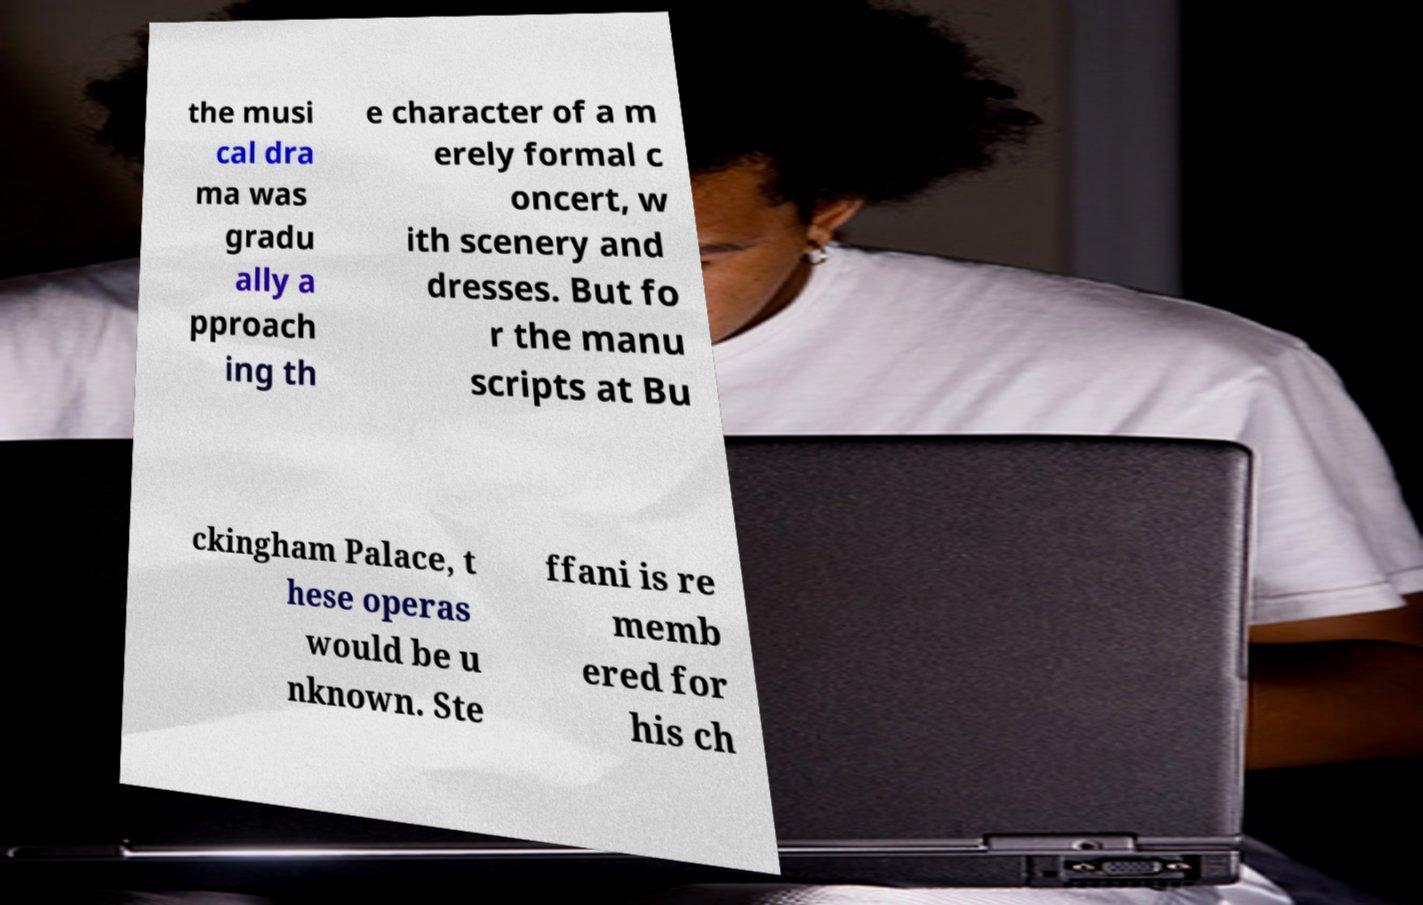For documentation purposes, I need the text within this image transcribed. Could you provide that? the musi cal dra ma was gradu ally a pproach ing th e character of a m erely formal c oncert, w ith scenery and dresses. But fo r the manu scripts at Bu ckingham Palace, t hese operas would be u nknown. Ste ffani is re memb ered for his ch 